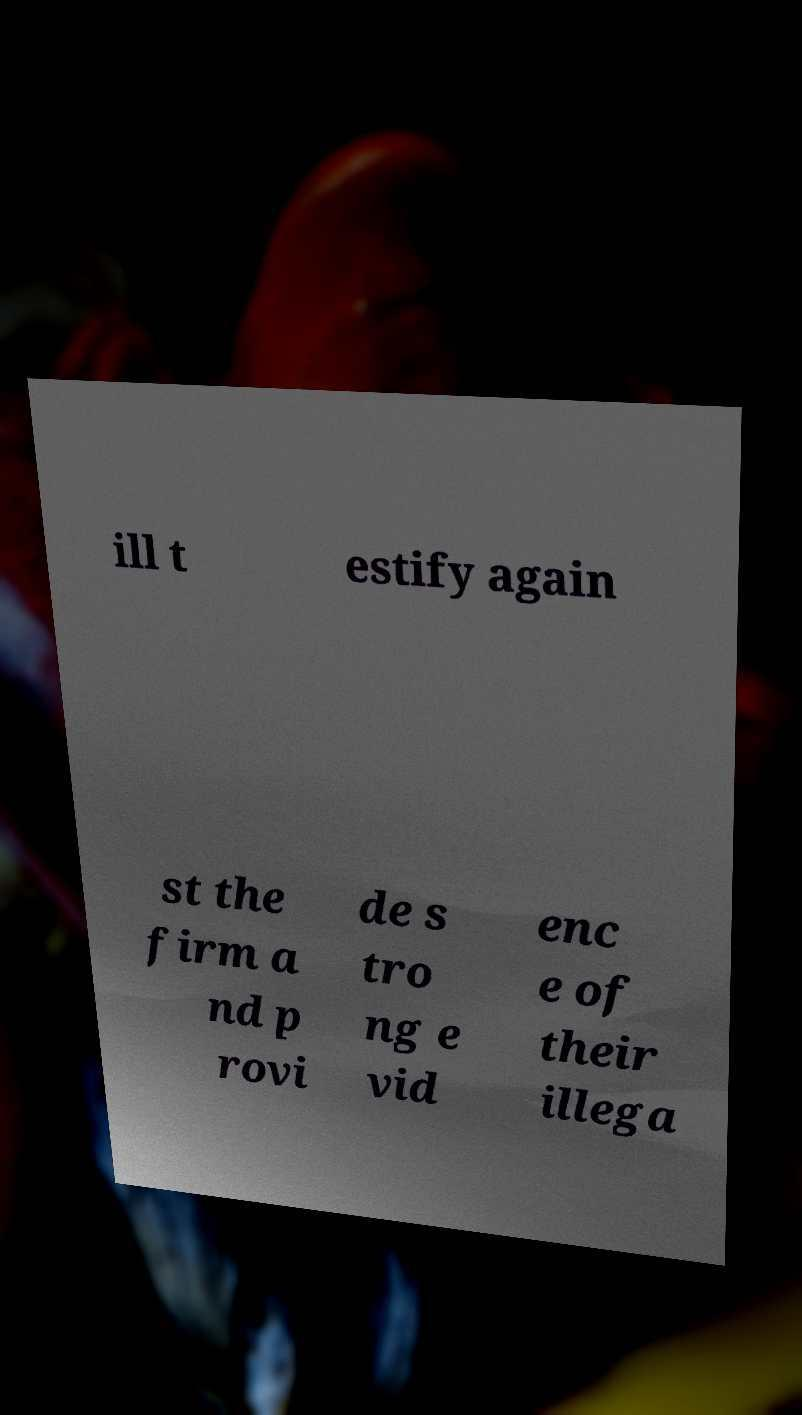Can you accurately transcribe the text from the provided image for me? ill t estify again st the firm a nd p rovi de s tro ng e vid enc e of their illega 